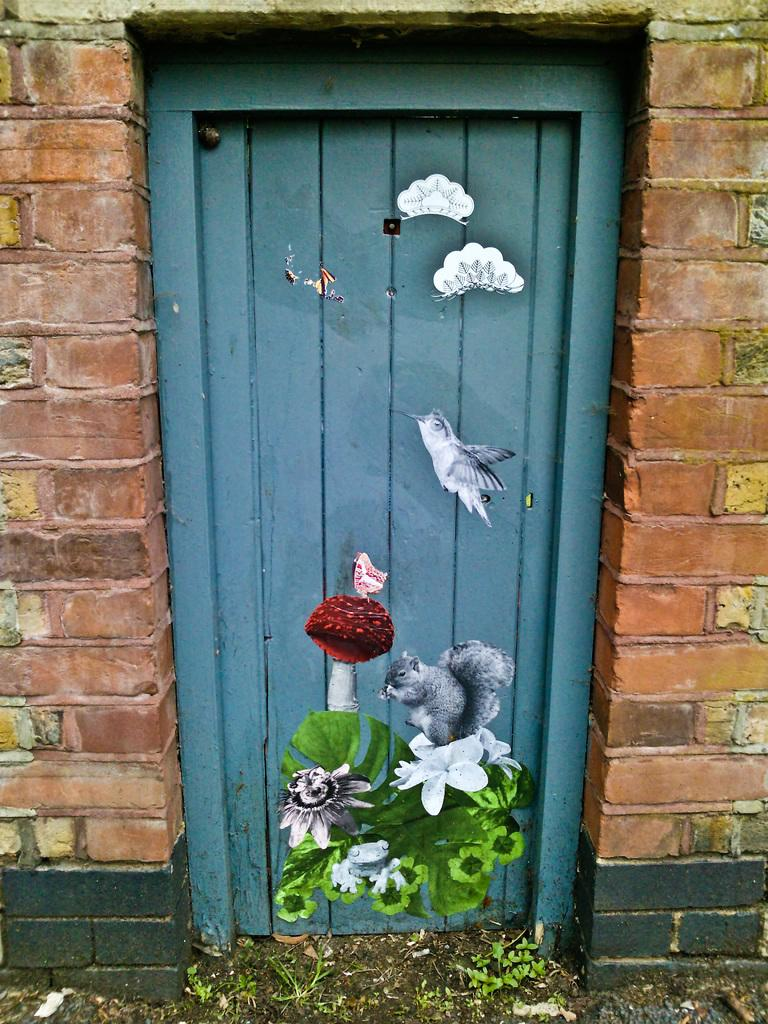What type of structure can be seen in the image? There are walls in the image, which suggests a building or room. Is there any entrance visible in the image? Yes, there is a door in the image. What is unique about the door in the image? The door has a painting on it. Can you describe the painting on the door? The painting includes an animal, a bird, a mushroom, and flowers. What type of peace symbol can be seen on the elbow of the animal in the painting? There is no peace symbol or elbow present in the painting; it only includes an animal, a bird, a mushroom, and flowers. 